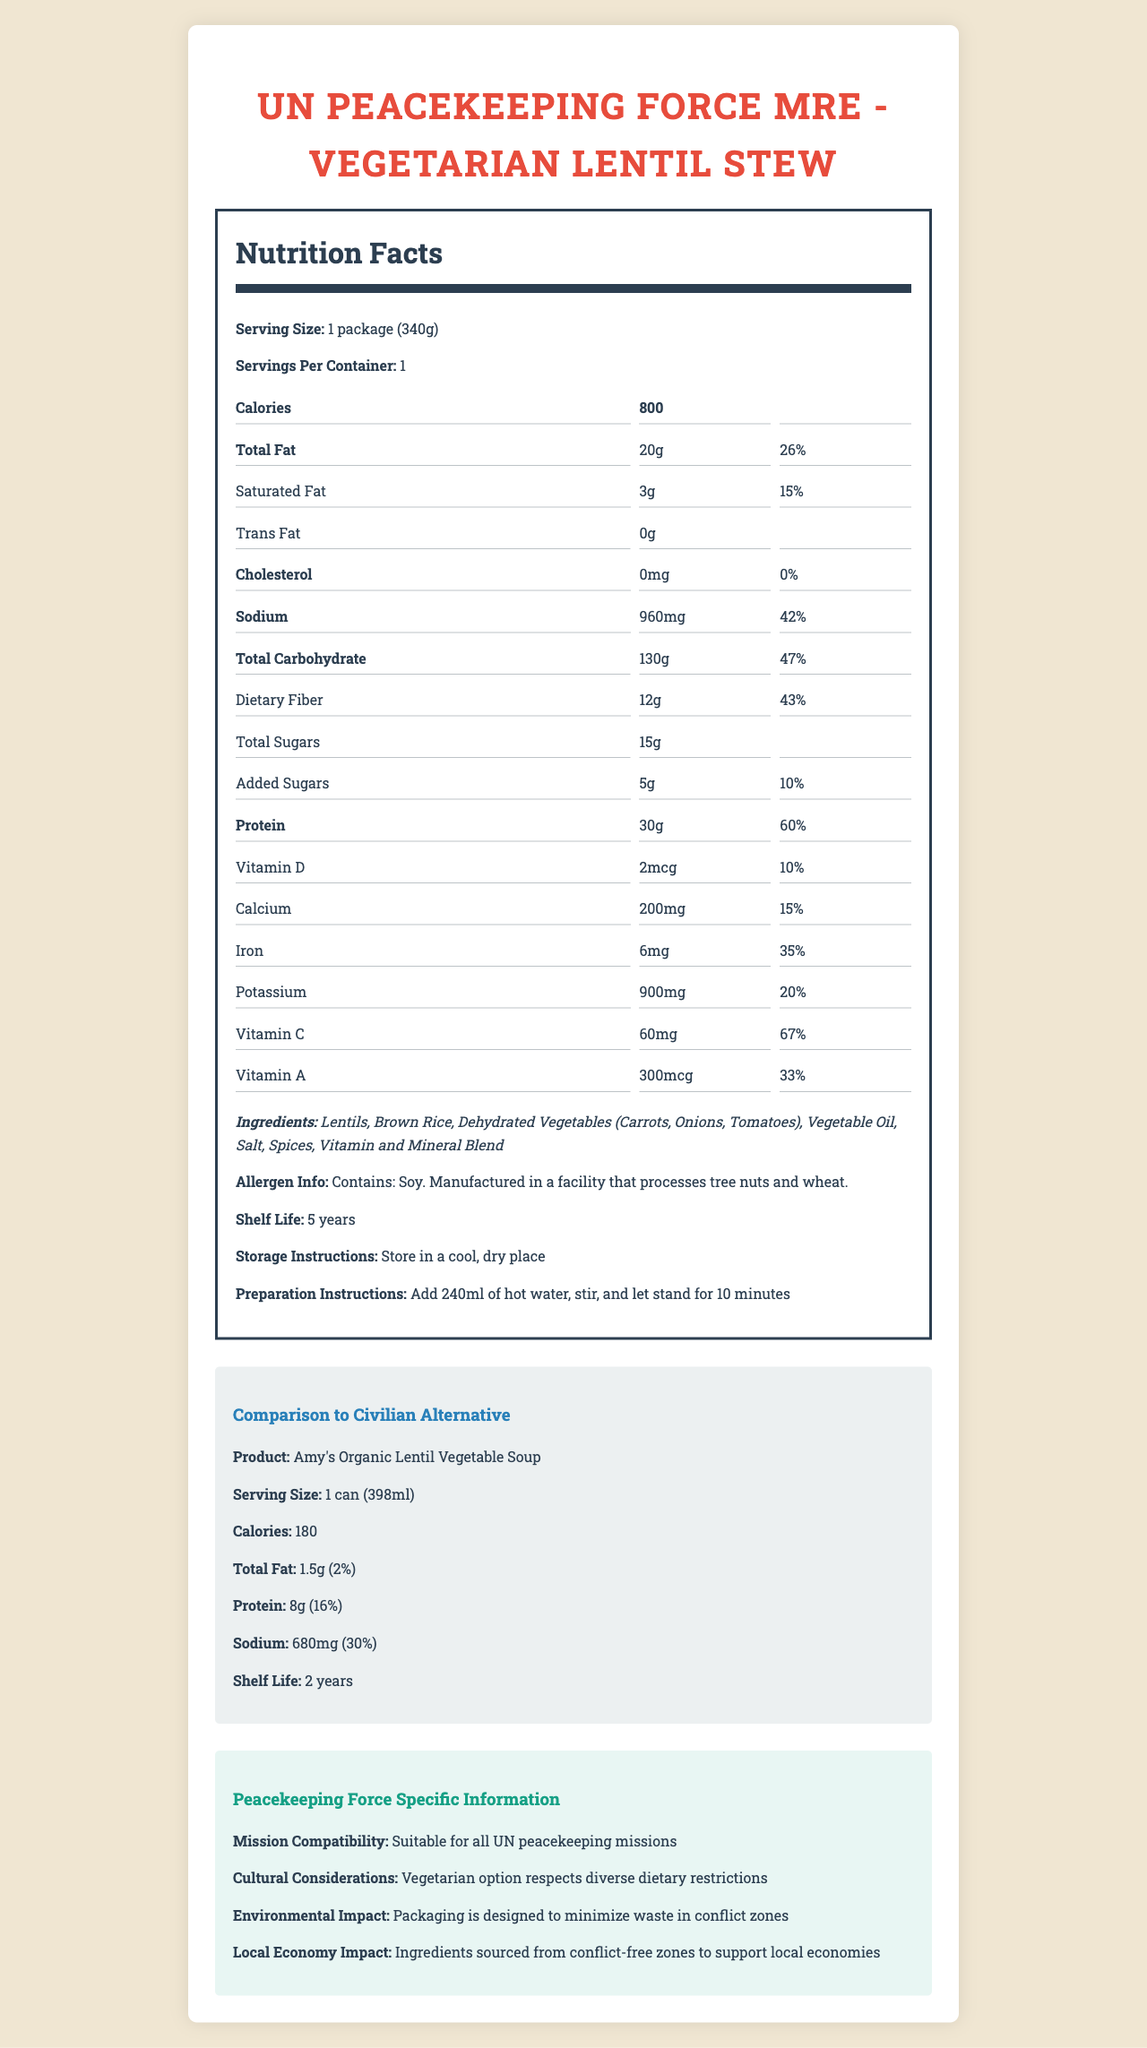what is the serving size of the UN Peacekeeping Force MRE? The serving size is listed as "1 package (340g)" in the Nutrition Facts section.
Answer: 1 package (340g) how many calories does the UN Peacekeeping Force MRE provide per serving? The Nutrition Facts section specifies that there are 800 calories per serving.
Answer: 800 what is the total carbohydrate content in the civilian alternative? The total carbohydrate content in the comparison section is 130g for the UN Peacekeeping Force MRE.
Answer: 130g what are the main ingredients in the UN Peacekeeping Force MRE? The ingredients are listed under the Ingredients section.
Answer: Lentils, Brown Rice, Dehydrated Vegetables (Carrots, Onions, Tomatoes), Vegetable Oil, Salt, Spices, Vitamin and Mineral Blend how much sodium does the civilian alternative contain? The comparison section indicates that Amy's Organic Lentil Vegetable Soup contains 680mg of sodium.
Answer: 680mg compare the protein content between the MRE and the civilian alternative. (A. MRE has more protein B. Civilian alternative has more protein C. Both have the same amount of protein) The MRE has 30g of protein, while the civilian alternative has only 8g, making the MRE the one with more protein.
Answer: A. MRE has more protein what is the shelf life of the UN Peacekeeping Force MRE? The shelf life is stated to be 5 years in the document.
Answer: 5 years does the MRE contain any allergens? (Yes/No) The allergen information mentions that the MRE contains soy and is manufactured in a facility that processes tree nuts and wheat.
Answer: Yes what are the peacekeeping force-specific characteristics of the MRE? These details are listed under the Peacekeeping Force Specific Information section.
Answer: Suitable for all UN peacekeeping missions, vegetarian option respects diverse dietary restrictions, packaging designed to minimize waste in conflict zones, ingredients sourced from conflict-free zones to support local economies why is the MRE suitable for peacekeeping missions? This information is provided in the peacekeeping force-specific information section.
Answer: Suitable for all UN peacekeeping missions due to its vegetarian option, diverse dietary respect, and minimal waste packaging how should the UN Peacekeeping Force MRE be prepared? These instructions are under the Preparation Instructions section.
Answer: Add 240ml of hot water, stir, and let stand for 10 minutes what is the total fat content and daily value percentage for the UN Peacekeeping Force MRE? The total fat content is 20g, contributing to 26% of the daily value as per the Nutrition Facts section.
Answer: 20g (26%) how much vitamin C does the UN Peacekeeping Force MRE provide, and what percentage of the daily value does it cover? The MRE provides 60mg of vitamin C, which covers 67% of the daily value.
Answer: 60mg (67%) how does the environmental impact of the MRE benefit peacekeeping missions? The document details this in the Peacekeeping Force Specific Information section.
Answer: Packaging is designed to minimize waste in conflict zones how many calories does the civilian alternative contain? The comparison section mentions that Amy's Organic Lentil Vegetable Soup contains 180 calories.
Answer: 180 is the MRE or the civilian alternative higher in sodium content? (A. MRE B. Civilian alternative C. Both have the same amount) The MRE has 960mg of sodium versus the civilian alternative's 680mg, making the MRE higher in sodium content.
Answer: A. MRE what information can you find about the cultural considerations of the MRE? This is mentioned under the cultural considerations in the Peacekeeping Force Specific Information section.
Answer: Vegetarian option respects diverse dietary restrictions which product has a longer shelf life? (A. MRE B. Civilian alternative C. Both have the same shelf life) The MRE has a shelf life of 5 years compared to the civilian alternative's 2 years.
Answer: A. MRE summarize the main idea of the document. The document serves to inform about the nutritional content, preparation, shelf life, and suitability of the MRE for peacekeeping missions while drawing comparisons with a standard civilian alternative product.
Answer: The document provides detailed nutritional information about the UN Peacekeeping Force MRE - Vegetarian Lentil Stew, its comparison with a civilian alternative, and peacekeeping force-specific information such as mission compatibility, cultural considerations, environmental impact, and local economy impact. what is the price of the MRE compared to the civilian alternative? The document does not provide any information regarding the price of either the MRE or the civilian alternative.
Answer: I don't know 